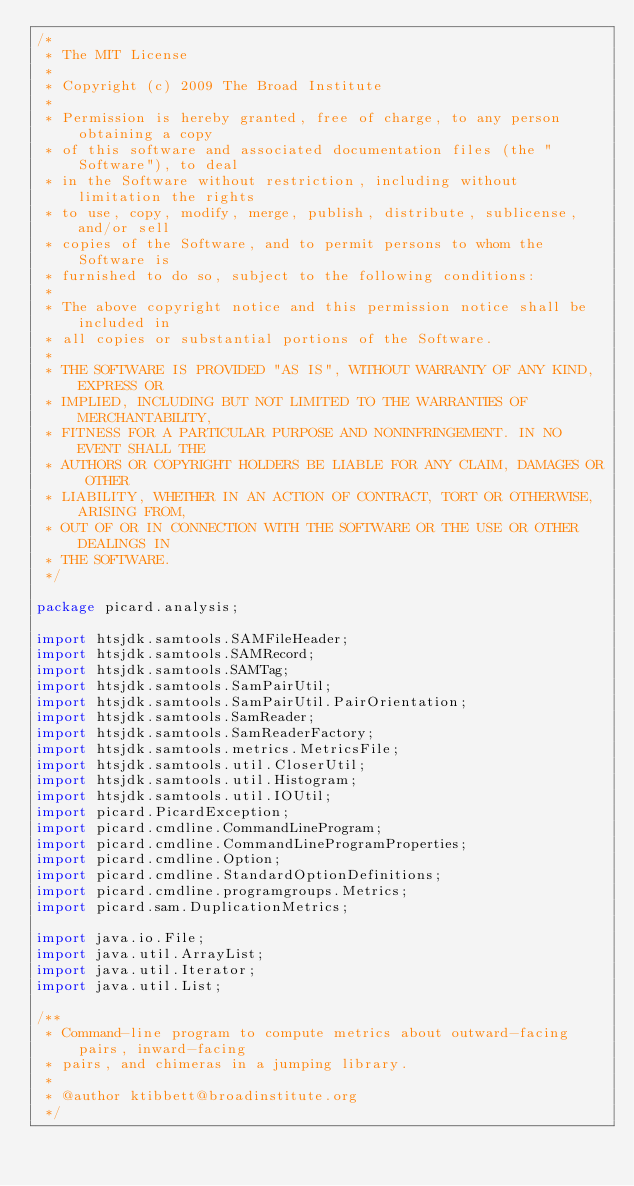<code> <loc_0><loc_0><loc_500><loc_500><_Java_>/*
 * The MIT License
 *
 * Copyright (c) 2009 The Broad Institute
 *
 * Permission is hereby granted, free of charge, to any person obtaining a copy
 * of this software and associated documentation files (the "Software"), to deal
 * in the Software without restriction, including without limitation the rights
 * to use, copy, modify, merge, publish, distribute, sublicense, and/or sell
 * copies of the Software, and to permit persons to whom the Software is
 * furnished to do so, subject to the following conditions:
 *
 * The above copyright notice and this permission notice shall be included in
 * all copies or substantial portions of the Software.
 *
 * THE SOFTWARE IS PROVIDED "AS IS", WITHOUT WARRANTY OF ANY KIND, EXPRESS OR
 * IMPLIED, INCLUDING BUT NOT LIMITED TO THE WARRANTIES OF MERCHANTABILITY,
 * FITNESS FOR A PARTICULAR PURPOSE AND NONINFRINGEMENT. IN NO EVENT SHALL THE
 * AUTHORS OR COPYRIGHT HOLDERS BE LIABLE FOR ANY CLAIM, DAMAGES OR OTHER
 * LIABILITY, WHETHER IN AN ACTION OF CONTRACT, TORT OR OTHERWISE, ARISING FROM,
 * OUT OF OR IN CONNECTION WITH THE SOFTWARE OR THE USE OR OTHER DEALINGS IN
 * THE SOFTWARE.
 */

package picard.analysis;

import htsjdk.samtools.SAMFileHeader;
import htsjdk.samtools.SAMRecord;
import htsjdk.samtools.SAMTag;
import htsjdk.samtools.SamPairUtil;
import htsjdk.samtools.SamPairUtil.PairOrientation;
import htsjdk.samtools.SamReader;
import htsjdk.samtools.SamReaderFactory;
import htsjdk.samtools.metrics.MetricsFile;
import htsjdk.samtools.util.CloserUtil;
import htsjdk.samtools.util.Histogram;
import htsjdk.samtools.util.IOUtil;
import picard.PicardException;
import picard.cmdline.CommandLineProgram;
import picard.cmdline.CommandLineProgramProperties;
import picard.cmdline.Option;
import picard.cmdline.StandardOptionDefinitions;
import picard.cmdline.programgroups.Metrics;
import picard.sam.DuplicationMetrics;

import java.io.File;
import java.util.ArrayList;
import java.util.Iterator;
import java.util.List;

/**
 * Command-line program to compute metrics about outward-facing pairs, inward-facing
 * pairs, and chimeras in a jumping library.
 *
 * @author ktibbett@broadinstitute.org
 */</code> 